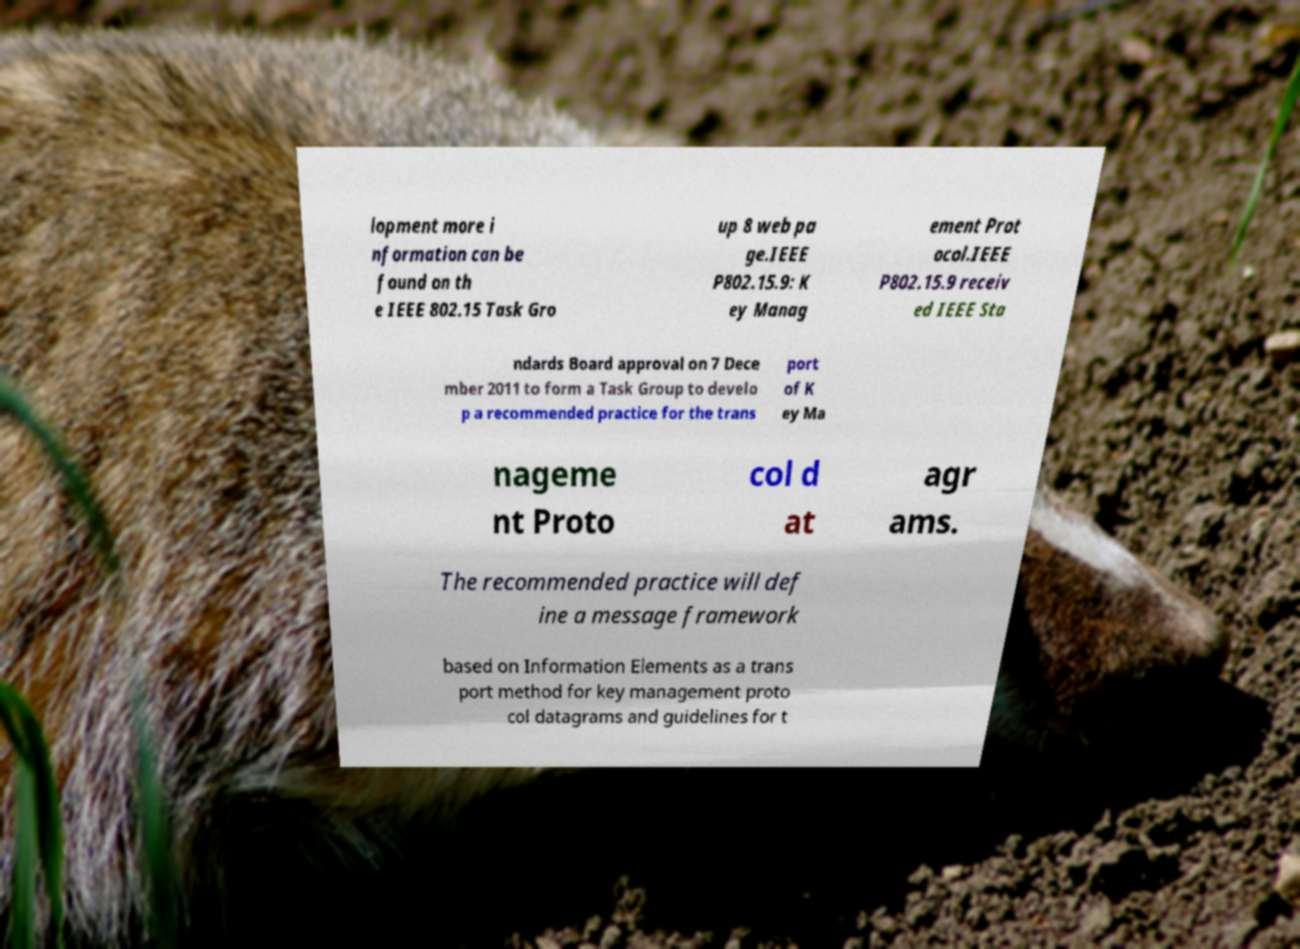For documentation purposes, I need the text within this image transcribed. Could you provide that? lopment more i nformation can be found on th e IEEE 802.15 Task Gro up 8 web pa ge.IEEE P802.15.9: K ey Manag ement Prot ocol.IEEE P802.15.9 receiv ed IEEE Sta ndards Board approval on 7 Dece mber 2011 to form a Task Group to develo p a recommended practice for the trans port of K ey Ma nageme nt Proto col d at agr ams. The recommended practice will def ine a message framework based on Information Elements as a trans port method for key management proto col datagrams and guidelines for t 